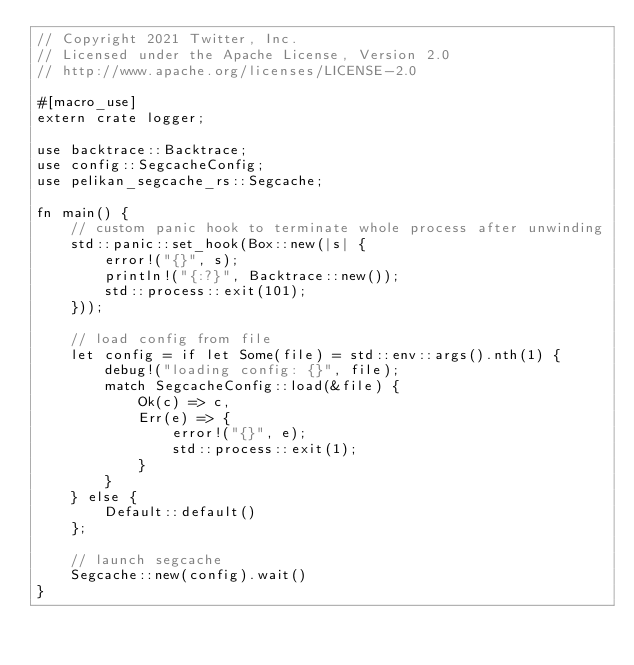<code> <loc_0><loc_0><loc_500><loc_500><_Rust_>// Copyright 2021 Twitter, Inc.
// Licensed under the Apache License, Version 2.0
// http://www.apache.org/licenses/LICENSE-2.0

#[macro_use]
extern crate logger;

use backtrace::Backtrace;
use config::SegcacheConfig;
use pelikan_segcache_rs::Segcache;

fn main() {
    // custom panic hook to terminate whole process after unwinding
    std::panic::set_hook(Box::new(|s| {
        error!("{}", s);
        println!("{:?}", Backtrace::new());
        std::process::exit(101);
    }));

    // load config from file
    let config = if let Some(file) = std::env::args().nth(1) {
        debug!("loading config: {}", file);
        match SegcacheConfig::load(&file) {
            Ok(c) => c,
            Err(e) => {
                error!("{}", e);
                std::process::exit(1);
            }
        }
    } else {
        Default::default()
    };

    // launch segcache
    Segcache::new(config).wait()
}
</code> 